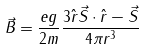Convert formula to latex. <formula><loc_0><loc_0><loc_500><loc_500>\vec { B } = \frac { e g } { 2 m } \frac { 3 \hat { r } \vec { S } \cdot \hat { r } - \vec { S } } { 4 \pi r ^ { 3 } }</formula> 